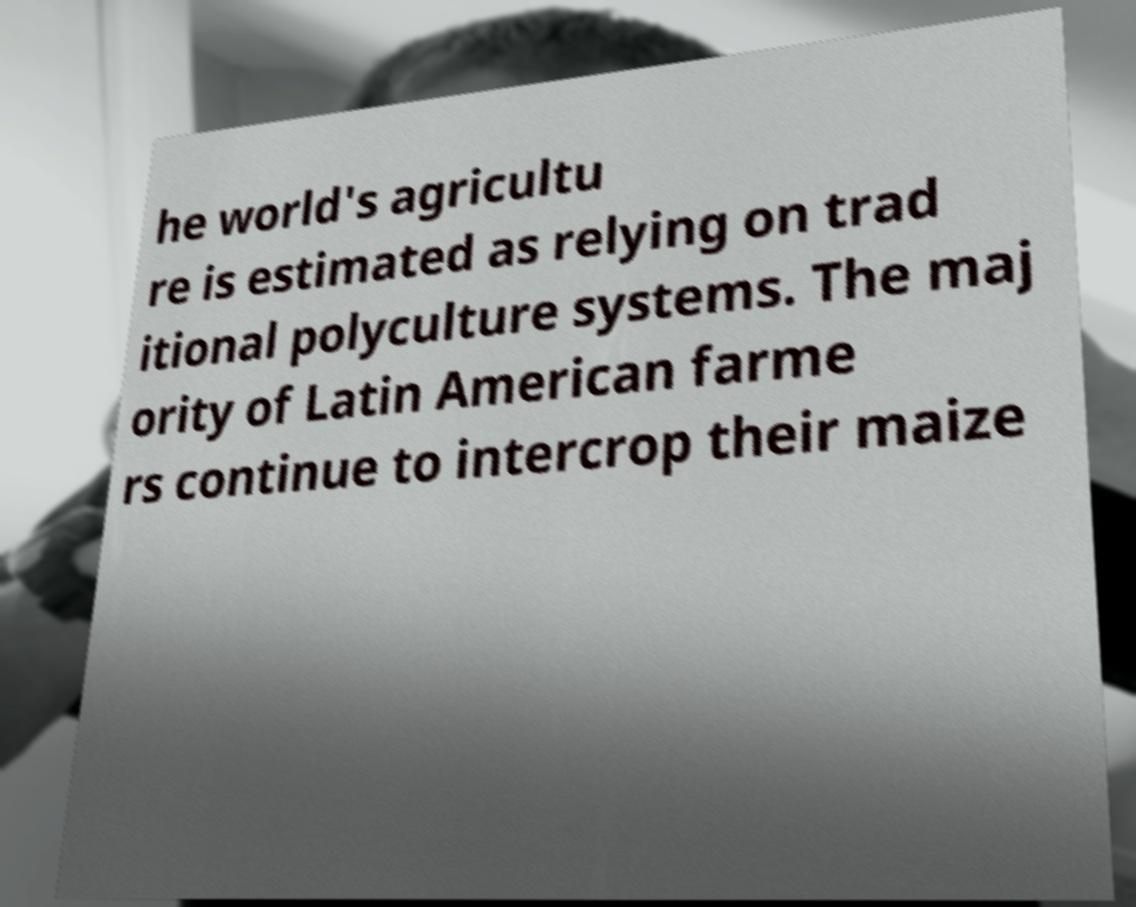Please identify and transcribe the text found in this image. he world's agricultu re is estimated as relying on trad itional polyculture systems. The maj ority of Latin American farme rs continue to intercrop their maize 